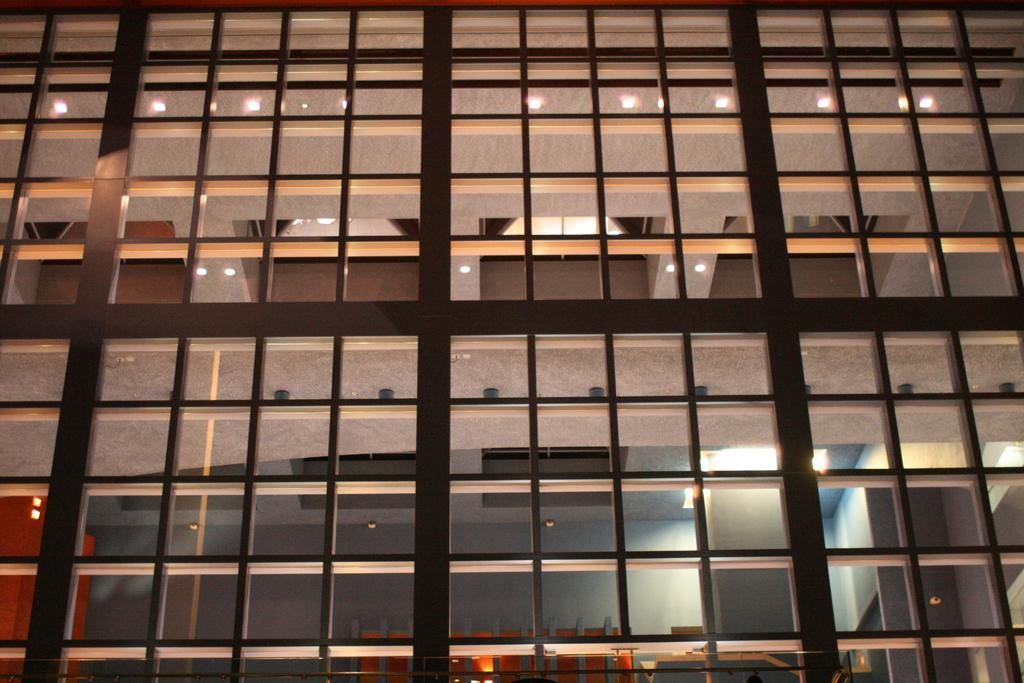What type of structure is visible in the image? There is a building in the image. What is unique about the building's walls? The building has glass walls. What other objects can be seen in the image? There are poles in the image. What is illuminating the area behind the glass walls? Lights are present on the pillars behind the glass walls. What type of banana is being blown by the verse in the image? There is no banana, blowing, or verse present in the image. 